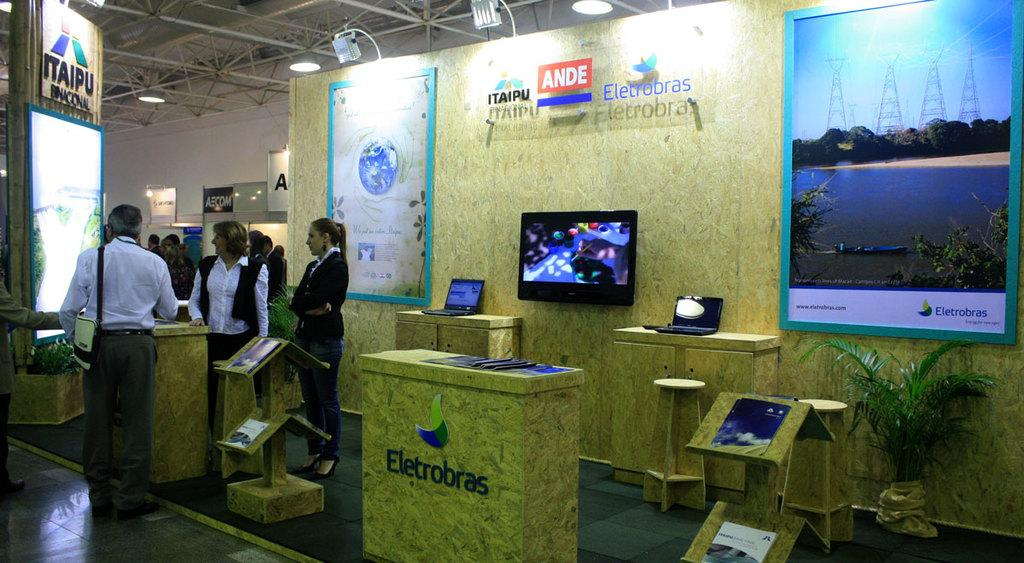<image>
Create a compact narrative representing the image presented. Group of people at a conference of some kind and the company is Eletrobras. 